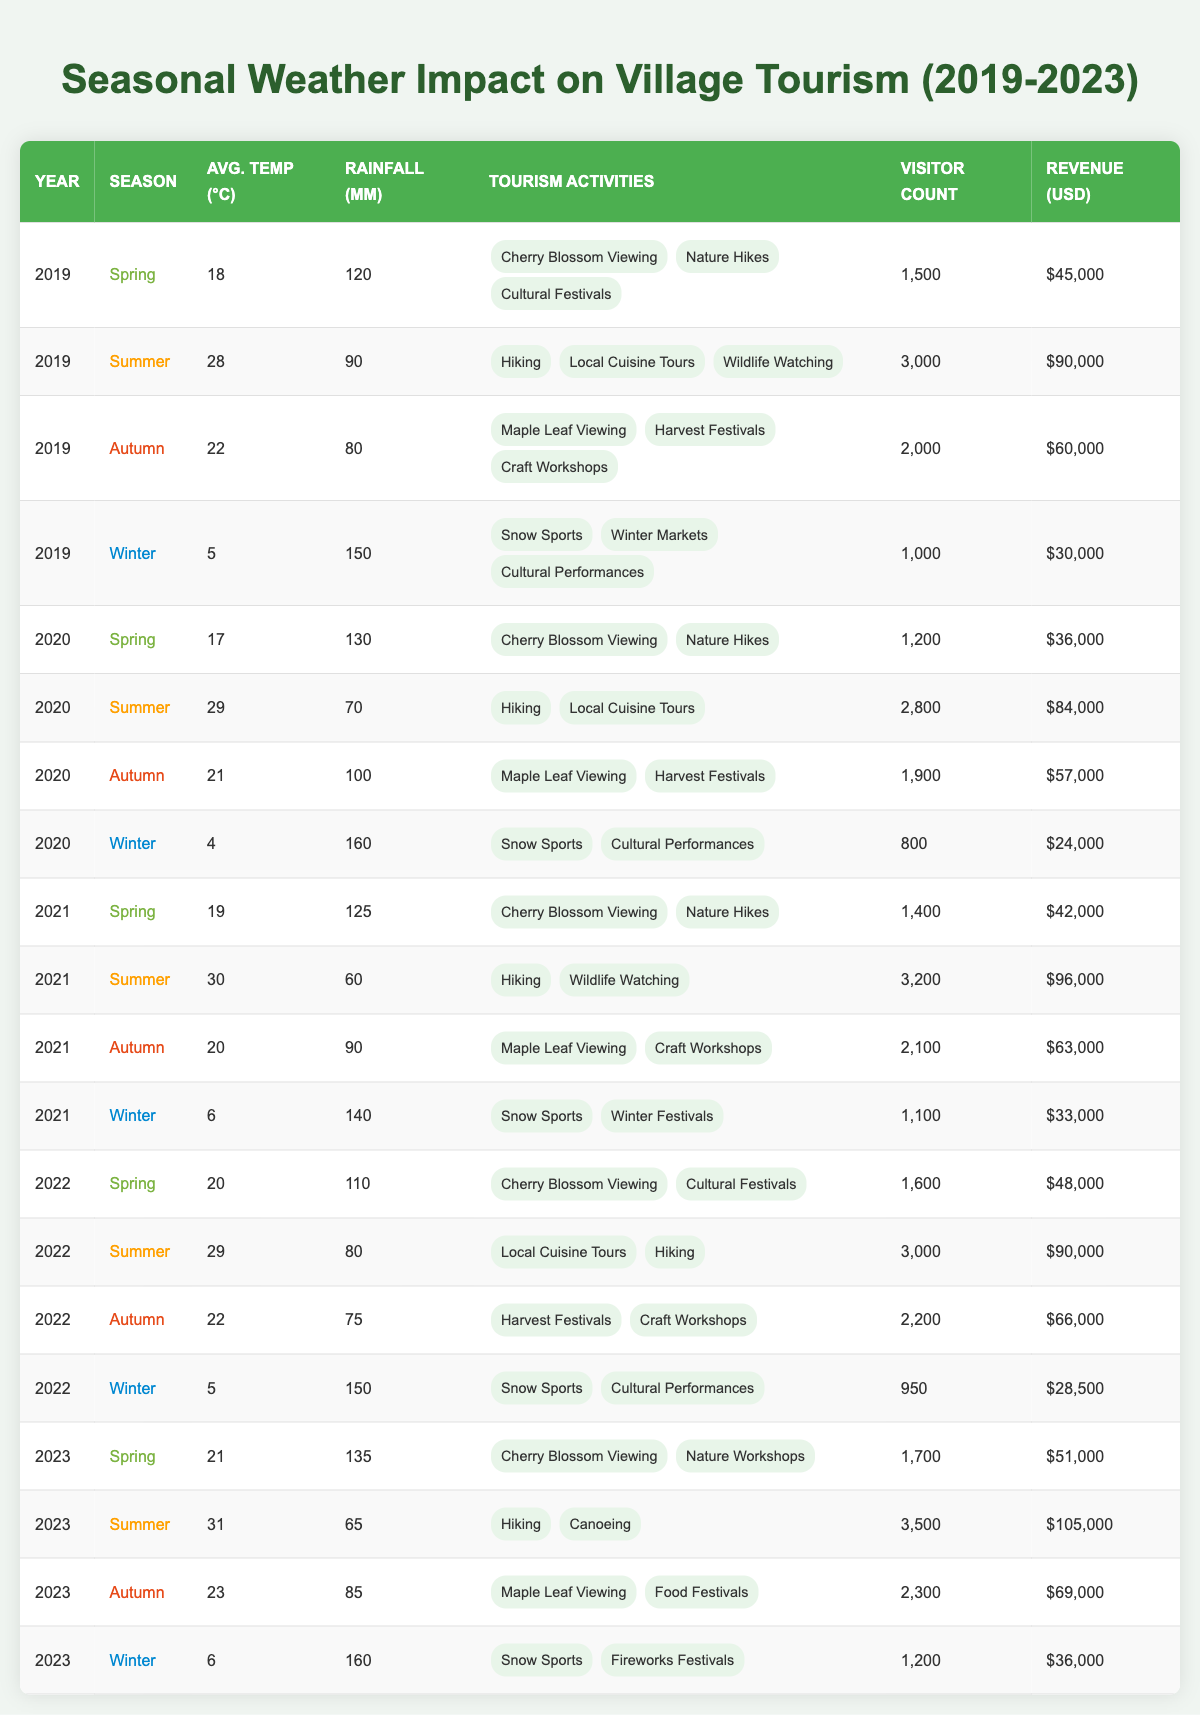What was the highest visitor count in 2022? The visitor count for each season in 2022 is: Spring: 1600, Summer: 3000, Autumn: 2200, Winter: 950. The highest is Summer with 3000 visitors.
Answer: 3000 In which year did the village have the highest revenue from tourism? The revenue for each year is as follows: 2019: 225000, 2020: 174000, 2021: 225000, 2022: 192500, 2023: 261000. The highest revenue was in 2023 with 261000 USD.
Answer: 2023 How many different tourism activities were available in the Summer of 2021? In Summer 2021, the activities were Hiking and Wildlife Watching. Thus, there are 2 different activities.
Answer: 2 What was the average rainfall during the Spring seasons from 2019 to 2023? The rainfall amounts from 2019 to 2023 Spring seasons are: 120mm, 130mm, 125mm, 110mm, and 135mm. The average is (120 + 130 + 125 + 110 + 135) / 5 = 124mm.
Answer: 124mm Is the average temperature in Winter higher than in Spring for any year? The average temperatures in Winter and Spring for each year are: 2019: Winter 5, Spring 18; 2020: Winter 4, Spring 17; 2021: Winter 6, Spring 19; 2022: Winter 5, Spring 20; 2023: Winter 6, Spring 21. In all cases, Winter temperatures are lower than Spring.
Answer: No What was the total revenue generated during Autumn across all the years? The revenues for Autumn seasons are as follows: 2019: 60000, 2020: 57000, 2021: 63000, 2022: 66000, 2023: 69000. Summing these gives 60000 + 57000 + 63000 + 66000 + 69000 = 315000 USD.
Answer: 315000 Did visitor counts increase every year in the Summer season from 2019 to 2023? The visitor counts for Summer are: 2019: 3000, 2020: 2800, 2021: 3200, 2022: 3000, 2023: 3500. Since there is a decrease from 2019 to 2020 and from 2021 to 2022, the counts did not increase every year.
Answer: No Which season had the most tourism activities listed in 2020? In 2020, for Spring there were 2 activities, for Summer also 2, for Autumn there were 2, and for Winter, 2. All seasons had the same number, so there is no standout season.
Answer: None How much revenue was generated in Winter 2022 and how does it compare to 2021? The revenue generated in Winter 2022 was 28500 USD and in Winter 2021 it was 33000 USD. 28500 is less than 33000, showing a decrease of 4500 USD.
Answer: Less than 2021 What was the relationship between average temperature and visitor count in Summer 2023 compared to Winter 2023? In Summer 2023, the average temperature was 31°C with a visitor count of 3500, while in Winter 2023 it was 6°C with a visitor count of 1200. Higher temperature correlates with a higher visitor count.
Answer: The relationship shows that higher temperature leads to more visitors 